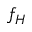Convert formula to latex. <formula><loc_0><loc_0><loc_500><loc_500>f _ { H }</formula> 